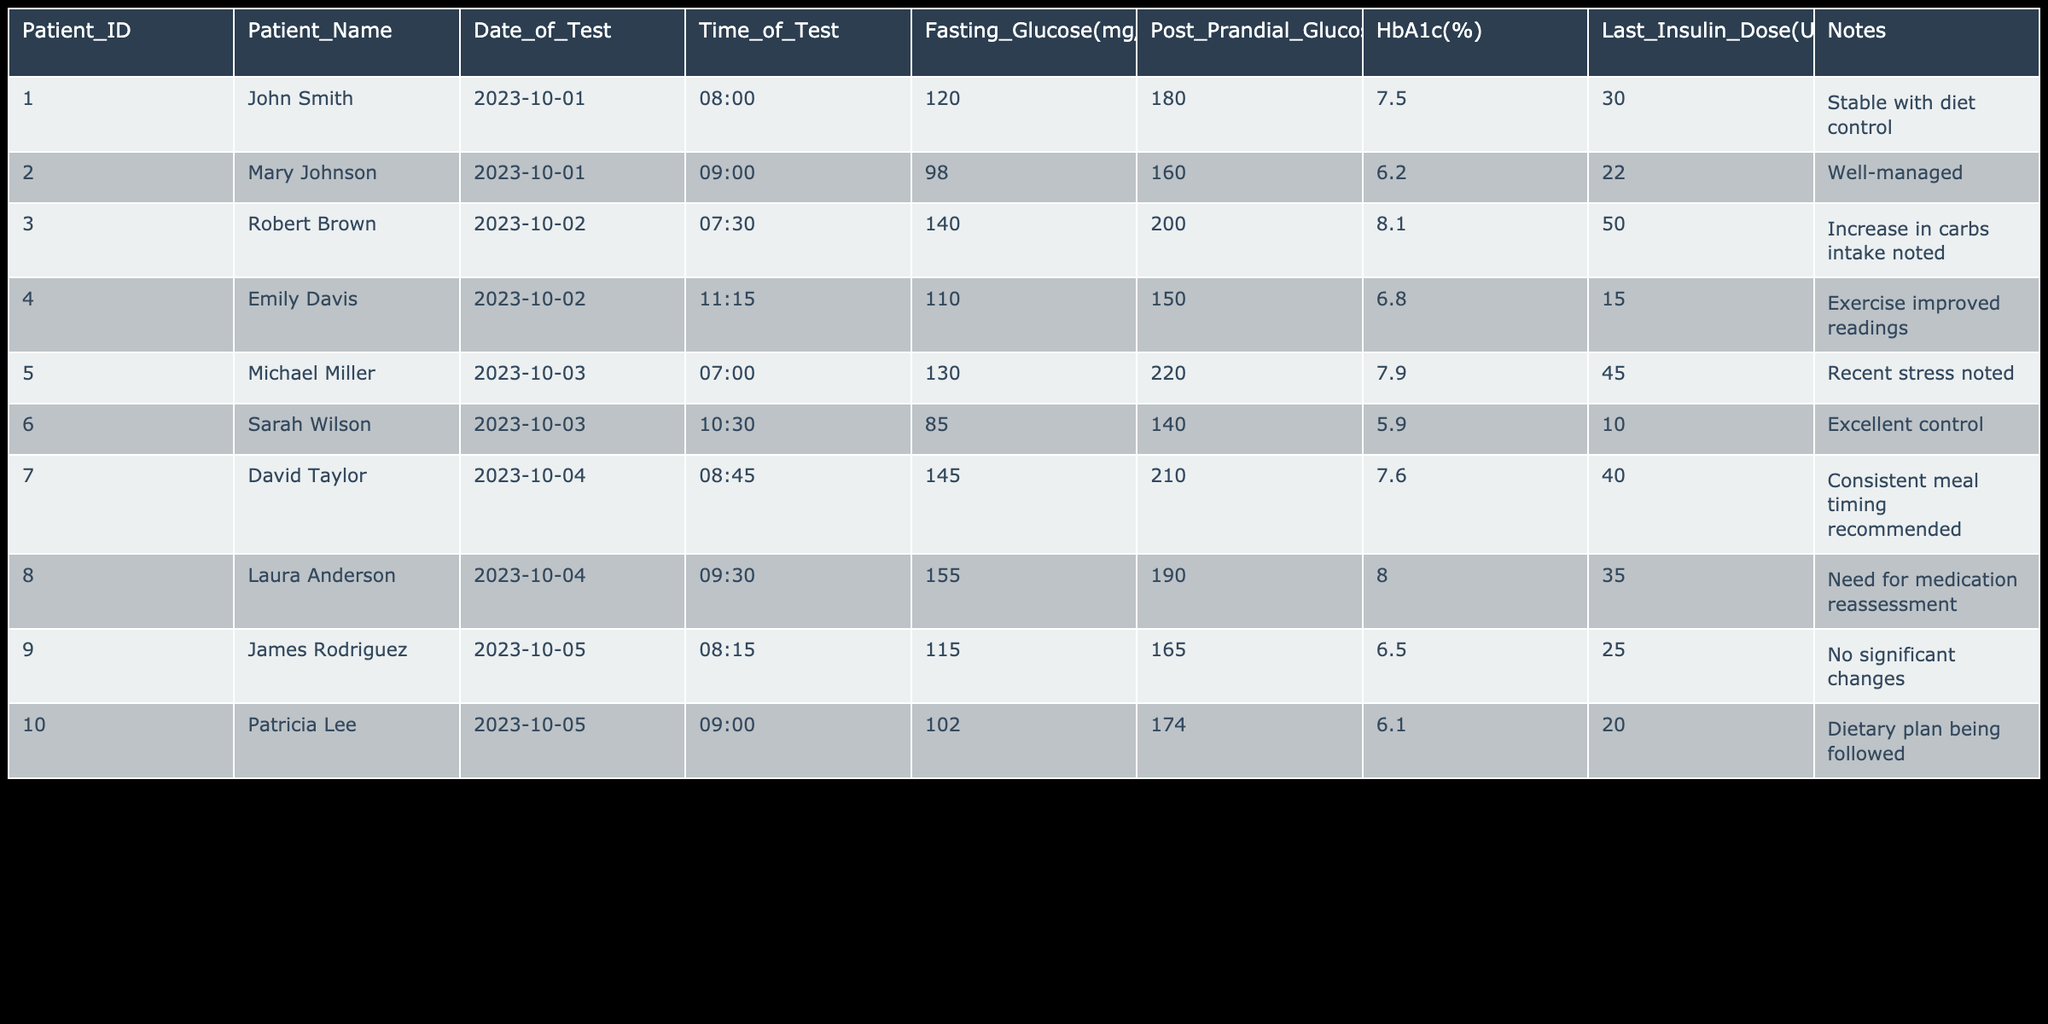What is the fasting glucose level for Sarah Wilson? According to the table, Sarah Wilson's fasting glucose level is listed in the column labeled 'Fasting_Glucose(mg/dL)'. For Patient_ID 006, the value is 85 mg/dL.
Answer: 85 mg/dL Which patient had the highest post-prandial glucose level? The highest post-prandial glucose level can be found in the 'Post_Prandial_Glucose(mg/dL)' column. By scanning through each row, Michael Miller has the highest value at 220 mg/dL.
Answer: Michael Miller What are the HbA1c levels for patients who administered over 30 units of insulin? To answer this, we check the 'Last_Insulin_Dose(U)' column for values greater than 30 and then refer to the corresponding 'HbA1c(%)' column. The respective HbA1c levels are 7.5, 8.1, and 7.6 for John Smith, Robert Brown, and David Taylor.
Answer: 7.5%, 8.1%, 7.6% Is Patricia Lee’s HbA1c level below 6.5%? Reviewing the 'HbA1c(%)' column for Patricia Lee (Patient_ID 010), her value is 6.1%, which is indeed below 6.5%.
Answer: Yes What is the average fasting glucose level of all patients in this table? To find the average fasting glucose level, we add all the fasting glucose values together: 120 + 98 + 140 + 110 + 130 + 85 + 145 + 155 + 115 + 102 = 1,100 mg/dL. There are 10 patients, so the average is 1,100 / 10 = 110 mg/dL.
Answer: 110 mg/dL Which patient has shown excellent control with a fasting glucose level below 90 mg/dL? Checking the 'Fasting_Glucose(mg/dL)' column, Sarah Wilson is the only patient with a level of 85 mg/dL, which is below 90 mg/dL, and she is noted for her excellent control.
Answer: Sarah Wilson How many patients have a post-prandial glucose level above 180 mg/dL? By evaluating the 'Post_Prandial_Glucose(mg/dL)' column, we see the patients with levels above 180 mg/dL are Robert Brown (200), Michael Miller (220), David Taylor (210), and Laura Anderson (190). There are 4 such patients.
Answer: 4 patients Has any patient mentioned stress in their notes? Looking through the 'Notes' column, Michael Miller states that "Recent stress noted," indicating that he is the only patient with a mention of stress.
Answer: Yes 